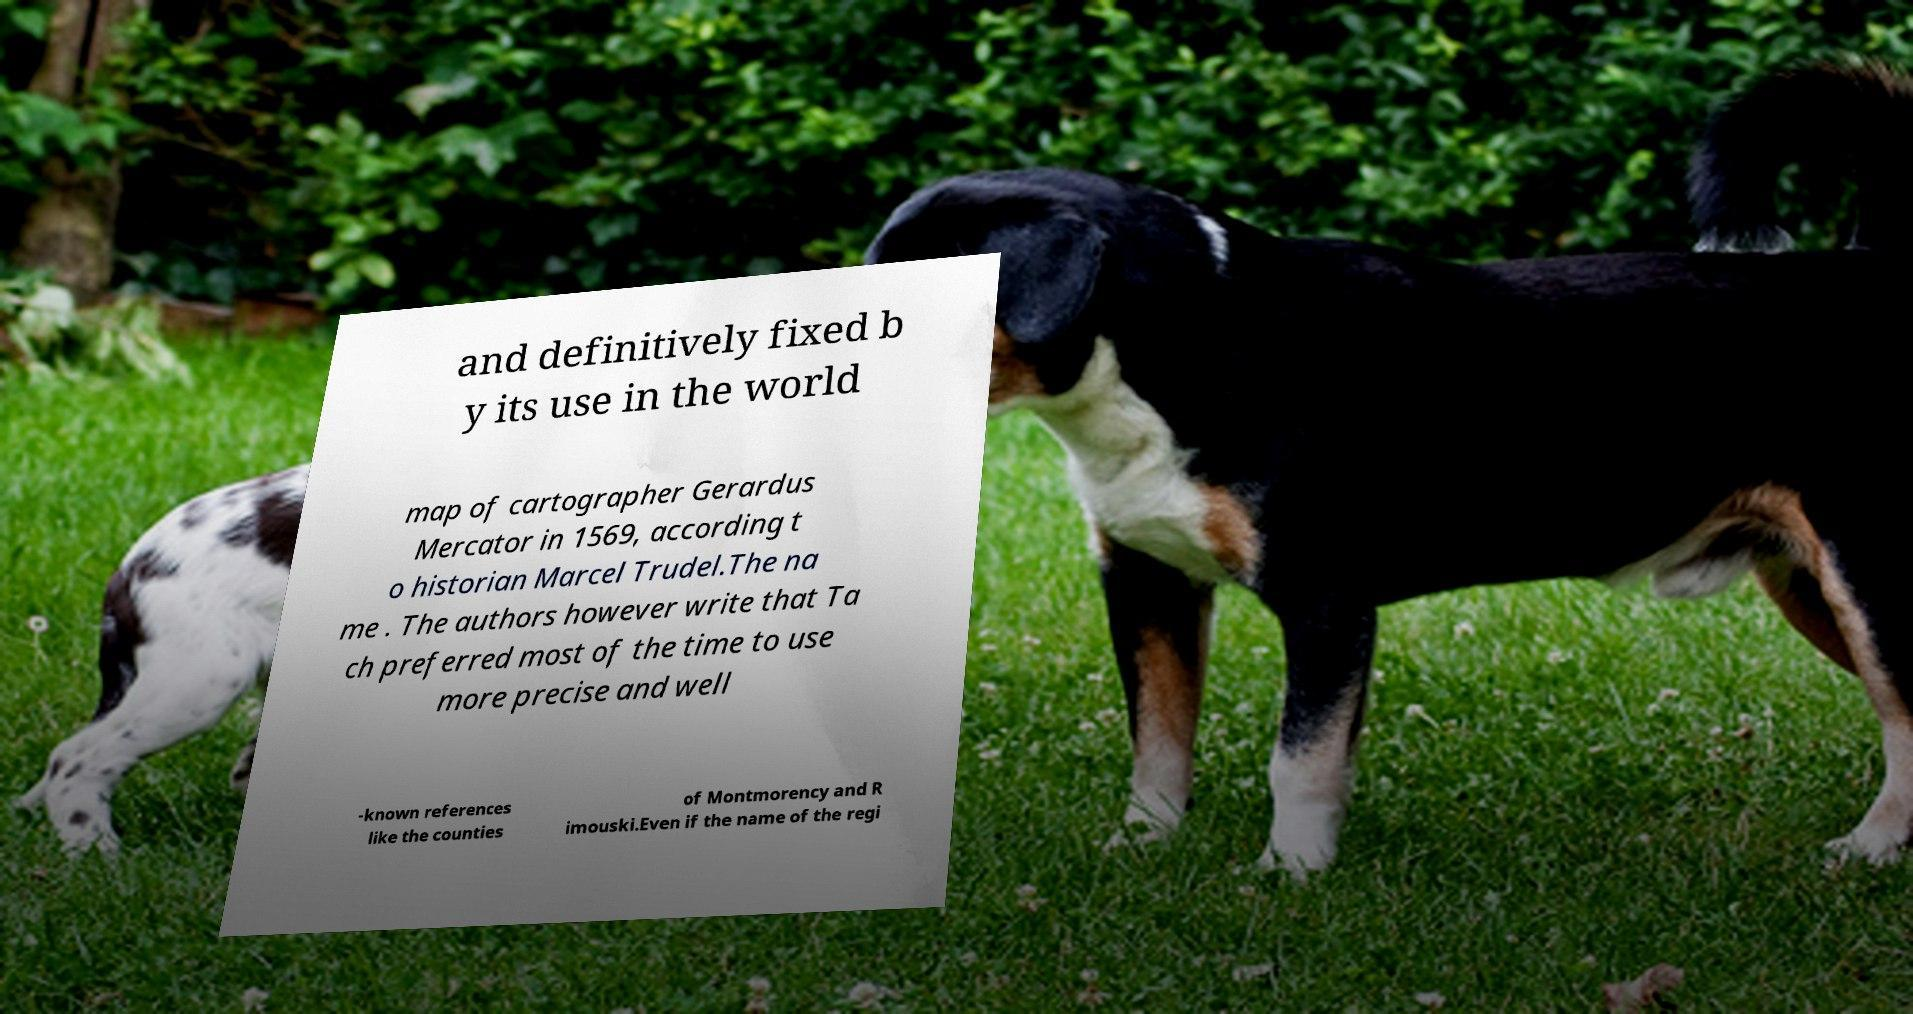What messages or text are displayed in this image? I need them in a readable, typed format. and definitively fixed b y its use in the world map of cartographer Gerardus Mercator in 1569, according t o historian Marcel Trudel.The na me . The authors however write that Ta ch preferred most of the time to use more precise and well -known references like the counties of Montmorency and R imouski.Even if the name of the regi 